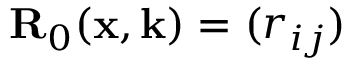<formula> <loc_0><loc_0><loc_500><loc_500>{ R } _ { 0 } ( x , k ) = ( r _ { i j } )</formula> 